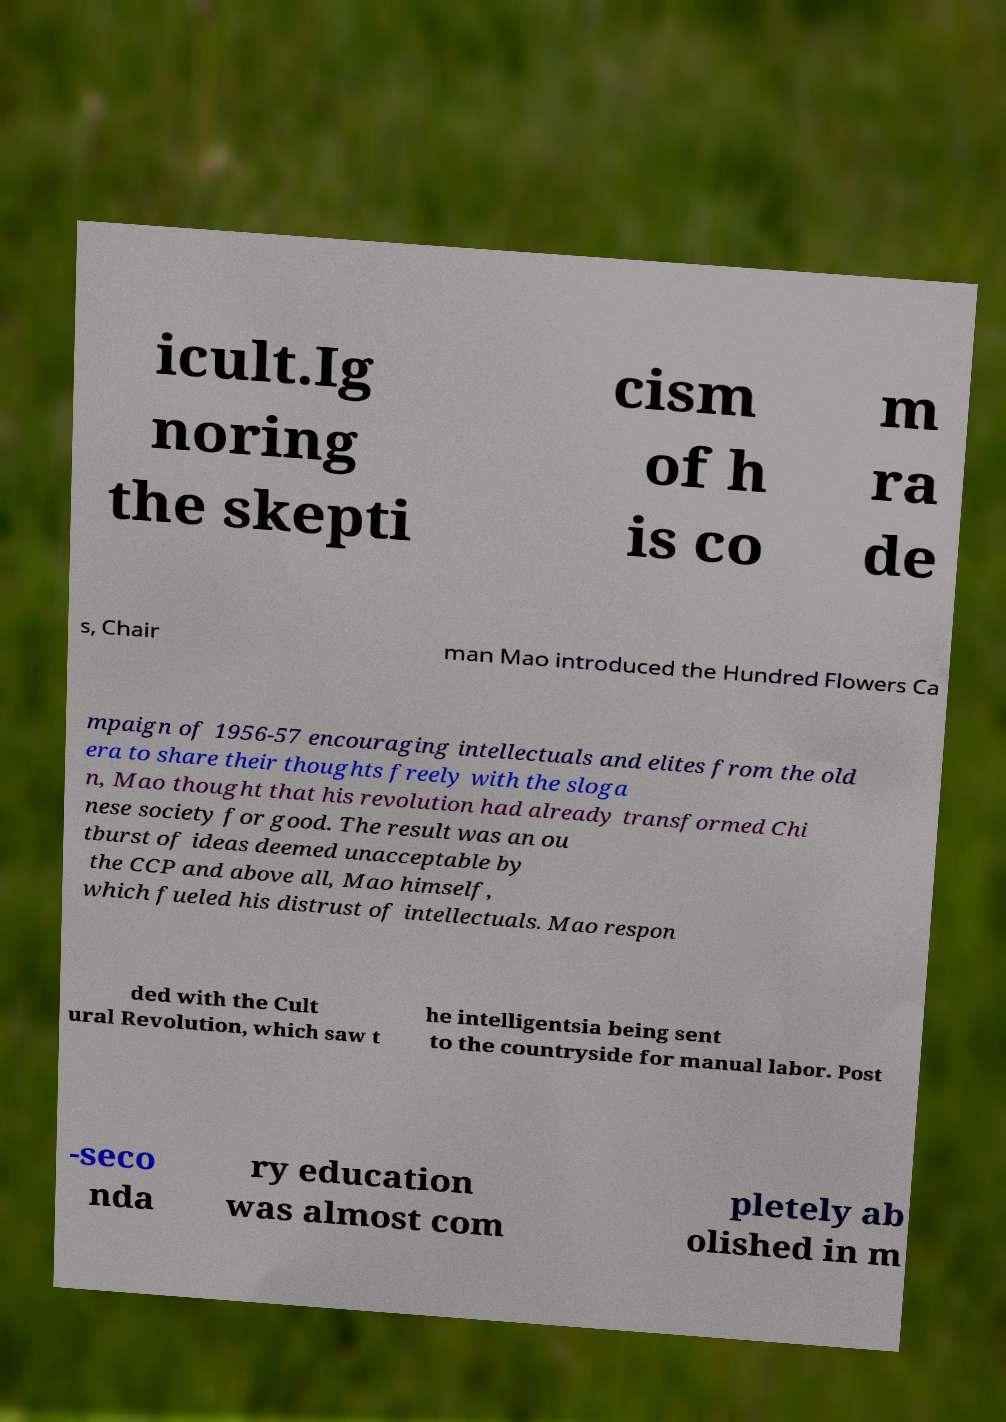Can you accurately transcribe the text from the provided image for me? icult.Ig noring the skepti cism of h is co m ra de s, Chair man Mao introduced the Hundred Flowers Ca mpaign of 1956-57 encouraging intellectuals and elites from the old era to share their thoughts freely with the sloga n, Mao thought that his revolution had already transformed Chi nese society for good. The result was an ou tburst of ideas deemed unacceptable by the CCP and above all, Mao himself, which fueled his distrust of intellectuals. Mao respon ded with the Cult ural Revolution, which saw t he intelligentsia being sent to the countryside for manual labor. Post -seco nda ry education was almost com pletely ab olished in m 